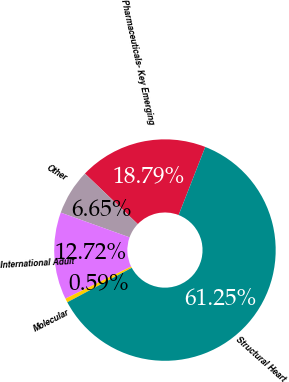Convert chart to OTSL. <chart><loc_0><loc_0><loc_500><loc_500><pie_chart><fcel>Pharmaceuticals- Key Emerging<fcel>Other<fcel>International Adult<fcel>Molecular<fcel>Structural Heart<nl><fcel>18.79%<fcel>6.65%<fcel>12.72%<fcel>0.59%<fcel>61.25%<nl></chart> 